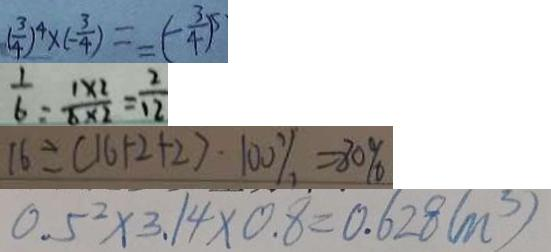<formula> <loc_0><loc_0><loc_500><loc_500>( \frac { 3 } { 4 } ) ^ { 4 } \times ( - \frac { 3 } { 4 } ) = - ( - \frac { 3 } { 4 } ) ^ { 5 } 
 \frac { 1 } { 6 } = \frac { 1 \times 2 } { 6 \times 2 } = \frac { 2 } { 1 2 } 
 1 6 \div ( 1 6 + 2 + 2 ) \cdot 1 0 0 \% = 8 0 \% 
 0 . 5 ^ { 2 } \times 3 . 1 4 \times 0 . 8 = 0 . 6 2 8 ( m ^ { 3 } )</formula> 